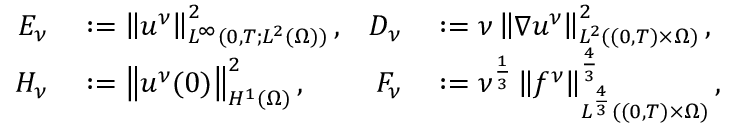<formula> <loc_0><loc_0><loc_500><loc_500>\begin{array} { r l r l } { E _ { \nu } } & \colon = \left \| u ^ { \nu } \right \| _ { L ^ { \infty } ( 0 , T ; L ^ { 2 } ( \Omega ) ) } ^ { 2 } , } & { D _ { \nu } } & \colon = \nu \left \| \nabla u ^ { \nu } \right \| _ { L ^ { 2 } ( ( 0 , T ) \times \Omega ) } ^ { 2 } , } \\ { H _ { \nu } } & \colon = \left \| u ^ { \nu } ( 0 ) \right \| _ { H ^ { 1 } ( \Omega ) } ^ { 2 } , } & { F _ { \nu } } & \colon = \nu ^ { \frac { 1 } { 3 } } \left \| f ^ { \nu } \right \| _ { L ^ { \frac { 4 } { 3 } } ( ( 0 , T ) \times \Omega ) } ^ { \frac { 4 } { 3 } } , } \end{array}</formula> 